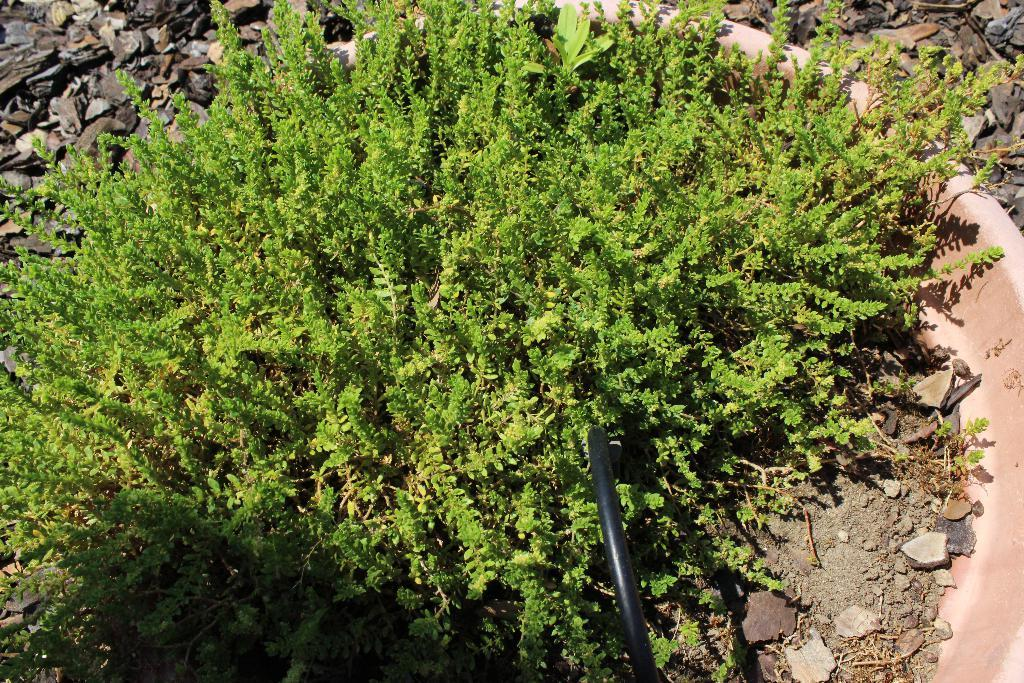What type of vegetation is present in the image? There are green plants in the image. What can be seen at the bottom of the image? There is a black pipe at the bottom of the image. What type of material is on the right side of the image? There are stones on the right side of the image. What type of calculator is visible in the image? There is no calculator present in the image. What type of trade is being conducted in the image? There is no trade being conducted in the image; it features green plants, a black pipe, and stones. 